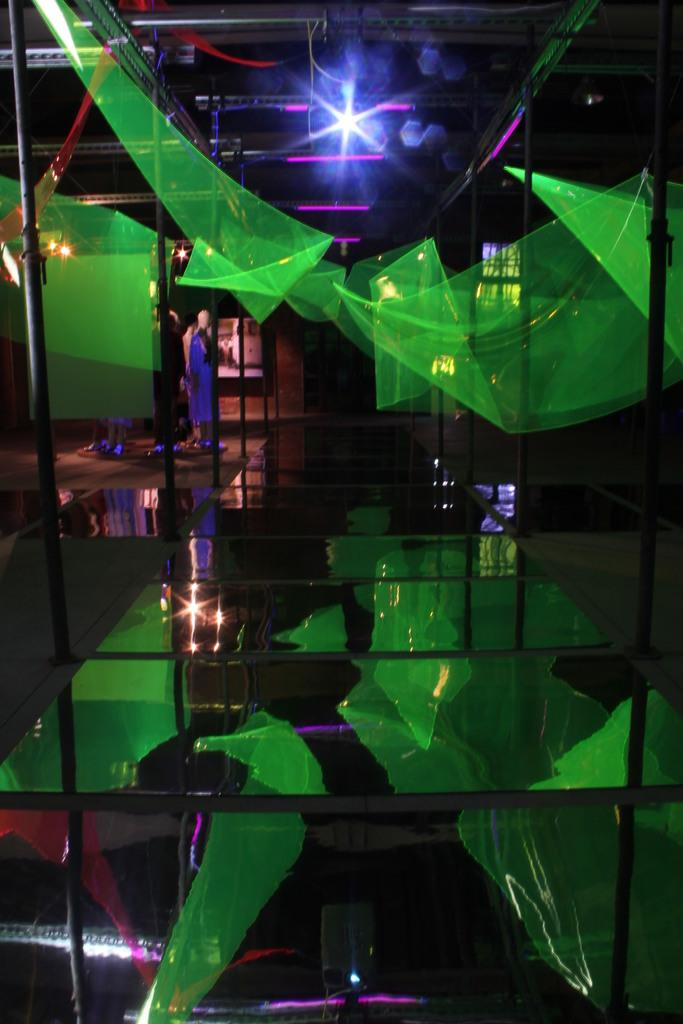What type of objects can be seen in the image? There are mannequins, poles, and lights in the image. What color are the green objects in the image? The green objects in the image are green. What is unique about the floor in the image? There is a glass floor in the image. What can be seen on the glass floor due to its reflective nature? Reflections are visible on the glass floor. What type of orange can be seen hanging from the poles in the image? There is no orange present in the image; the green objects mentioned are not oranges. 